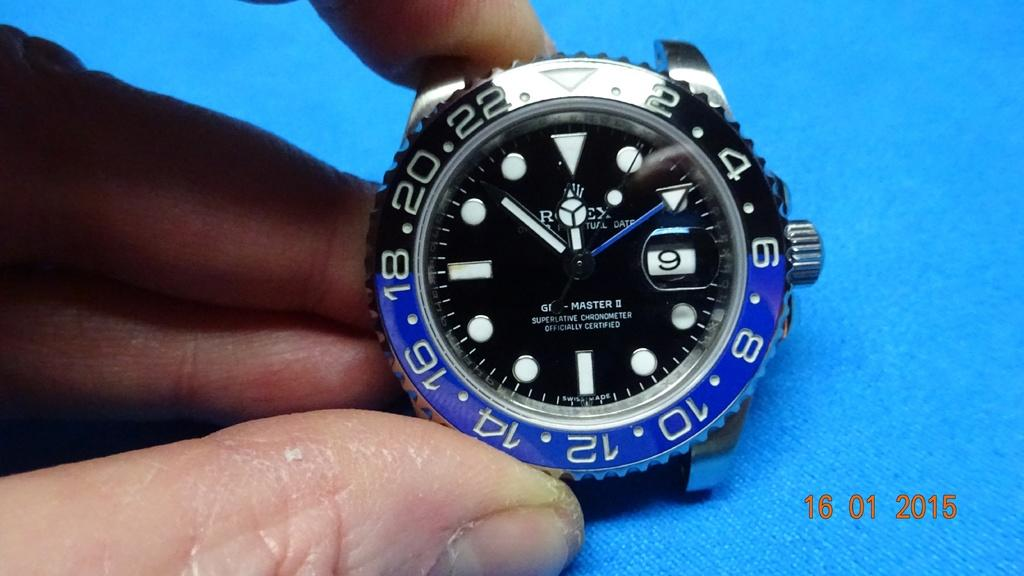<image>
Summarize the visual content of the image. A blue and silver Rolex watch is officially certified. 